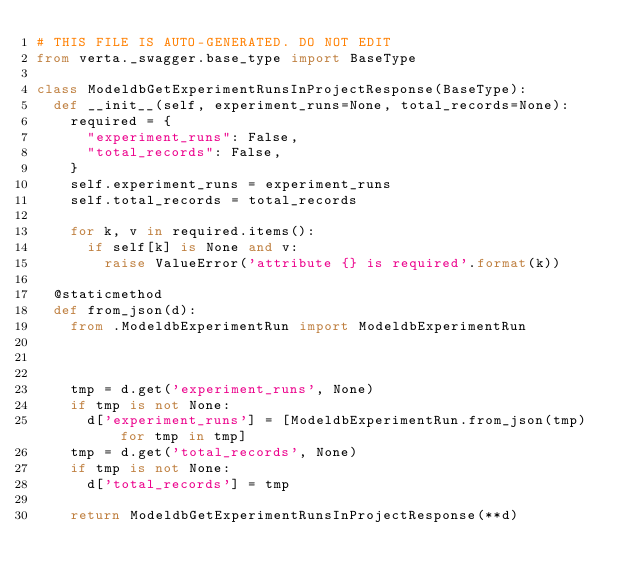Convert code to text. <code><loc_0><loc_0><loc_500><loc_500><_Python_># THIS FILE IS AUTO-GENERATED. DO NOT EDIT
from verta._swagger.base_type import BaseType

class ModeldbGetExperimentRunsInProjectResponse(BaseType):
  def __init__(self, experiment_runs=None, total_records=None):
    required = {
      "experiment_runs": False,
      "total_records": False,
    }
    self.experiment_runs = experiment_runs
    self.total_records = total_records

    for k, v in required.items():
      if self[k] is None and v:
        raise ValueError('attribute {} is required'.format(k))

  @staticmethod
  def from_json(d):
    from .ModeldbExperimentRun import ModeldbExperimentRun

    

    tmp = d.get('experiment_runs', None)
    if tmp is not None:
      d['experiment_runs'] = [ModeldbExperimentRun.from_json(tmp) for tmp in tmp]
    tmp = d.get('total_records', None)
    if tmp is not None:
      d['total_records'] = tmp

    return ModeldbGetExperimentRunsInProjectResponse(**d)
</code> 